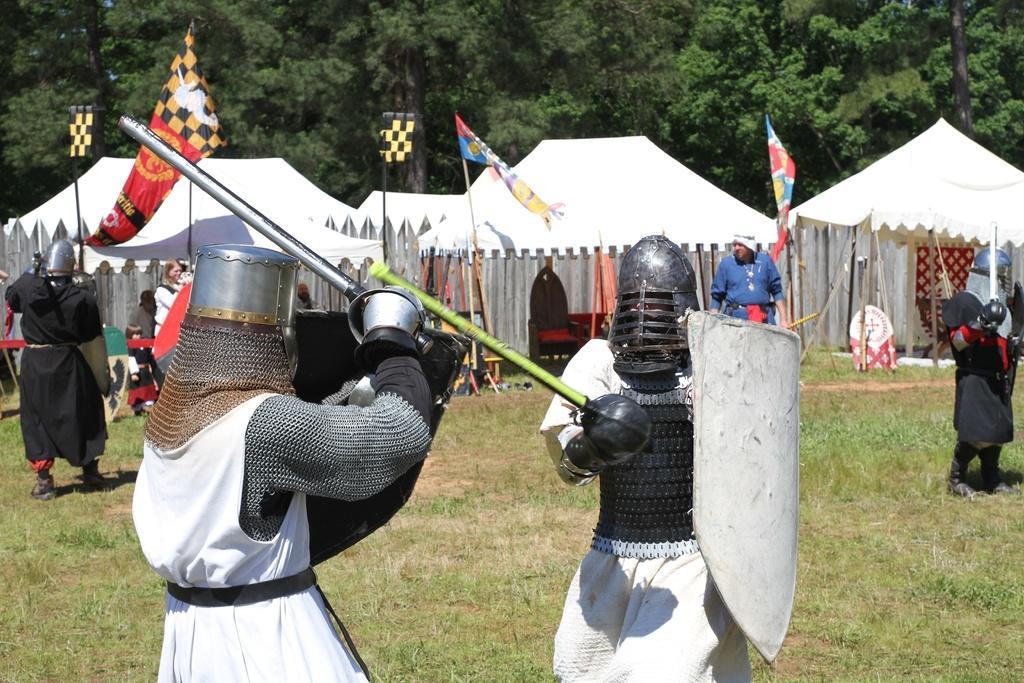Please provide a concise description of this image. In this picture I can observe two members fighting with each other. They are wearing helmets on their heads and holding shields in their hands. In the background I can observe tents and trees. 